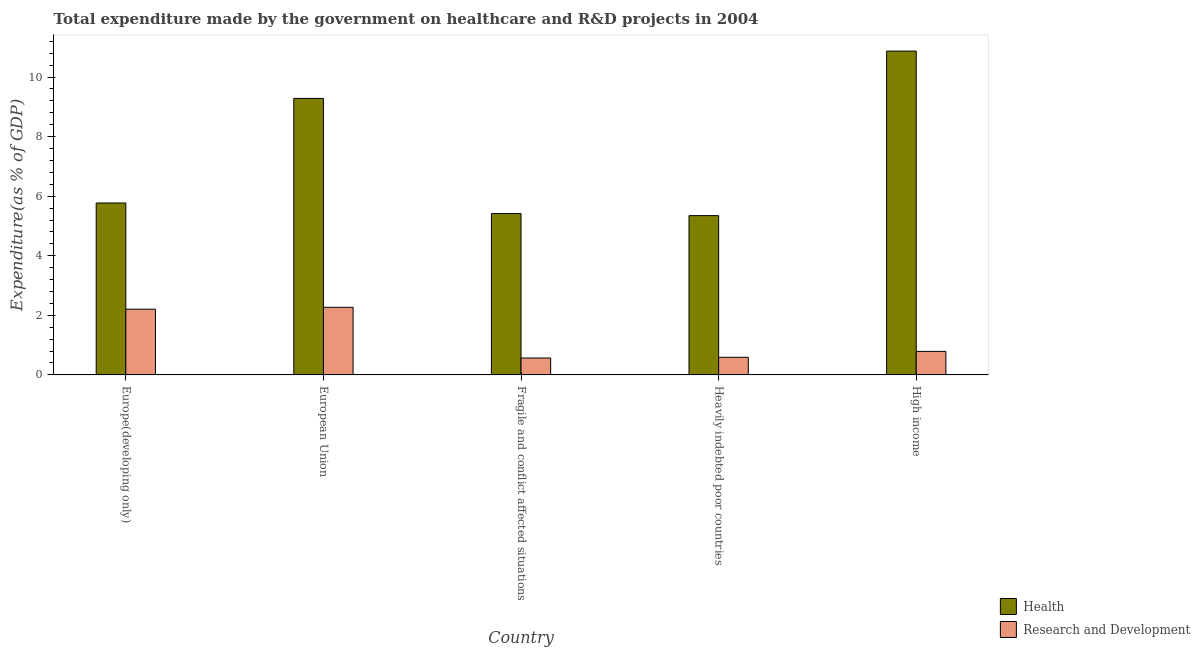How many different coloured bars are there?
Your answer should be very brief. 2. How many bars are there on the 3rd tick from the right?
Your answer should be very brief. 2. What is the label of the 4th group of bars from the left?
Provide a succinct answer. Heavily indebted poor countries. In how many cases, is the number of bars for a given country not equal to the number of legend labels?
Offer a terse response. 0. What is the expenditure in healthcare in Fragile and conflict affected situations?
Ensure brevity in your answer.  5.42. Across all countries, what is the maximum expenditure in healthcare?
Ensure brevity in your answer.  10.87. Across all countries, what is the minimum expenditure in healthcare?
Make the answer very short. 5.35. In which country was the expenditure in r&d maximum?
Provide a succinct answer. European Union. In which country was the expenditure in healthcare minimum?
Keep it short and to the point. Heavily indebted poor countries. What is the total expenditure in healthcare in the graph?
Offer a very short reply. 36.69. What is the difference between the expenditure in healthcare in European Union and that in Heavily indebted poor countries?
Your answer should be very brief. 3.94. What is the difference between the expenditure in r&d in European Union and the expenditure in healthcare in Fragile and conflict affected situations?
Make the answer very short. -3.15. What is the average expenditure in healthcare per country?
Provide a short and direct response. 7.34. What is the difference between the expenditure in r&d and expenditure in healthcare in Heavily indebted poor countries?
Offer a very short reply. -4.76. In how many countries, is the expenditure in healthcare greater than 6.4 %?
Offer a very short reply. 2. What is the ratio of the expenditure in healthcare in Fragile and conflict affected situations to that in High income?
Keep it short and to the point. 0.5. Is the expenditure in healthcare in Heavily indebted poor countries less than that in High income?
Offer a very short reply. Yes. What is the difference between the highest and the second highest expenditure in healthcare?
Offer a very short reply. 1.59. What is the difference between the highest and the lowest expenditure in healthcare?
Keep it short and to the point. 5.53. In how many countries, is the expenditure in r&d greater than the average expenditure in r&d taken over all countries?
Your answer should be very brief. 2. Is the sum of the expenditure in healthcare in European Union and Fragile and conflict affected situations greater than the maximum expenditure in r&d across all countries?
Offer a very short reply. Yes. What does the 2nd bar from the left in Fragile and conflict affected situations represents?
Provide a succinct answer. Research and Development. What does the 1st bar from the right in European Union represents?
Offer a terse response. Research and Development. How many countries are there in the graph?
Keep it short and to the point. 5. How many legend labels are there?
Ensure brevity in your answer.  2. How are the legend labels stacked?
Offer a terse response. Vertical. What is the title of the graph?
Your answer should be very brief. Total expenditure made by the government on healthcare and R&D projects in 2004. Does "Infant" appear as one of the legend labels in the graph?
Offer a very short reply. No. What is the label or title of the Y-axis?
Offer a terse response. Expenditure(as % of GDP). What is the Expenditure(as % of GDP) in Health in Europe(developing only)?
Provide a short and direct response. 5.77. What is the Expenditure(as % of GDP) of Research and Development in Europe(developing only)?
Make the answer very short. 2.21. What is the Expenditure(as % of GDP) of Health in European Union?
Offer a terse response. 9.28. What is the Expenditure(as % of GDP) of Research and Development in European Union?
Offer a terse response. 2.27. What is the Expenditure(as % of GDP) in Health in Fragile and conflict affected situations?
Offer a very short reply. 5.42. What is the Expenditure(as % of GDP) of Research and Development in Fragile and conflict affected situations?
Offer a very short reply. 0.57. What is the Expenditure(as % of GDP) in Health in Heavily indebted poor countries?
Your answer should be very brief. 5.35. What is the Expenditure(as % of GDP) in Research and Development in Heavily indebted poor countries?
Provide a short and direct response. 0.59. What is the Expenditure(as % of GDP) of Health in High income?
Provide a succinct answer. 10.87. What is the Expenditure(as % of GDP) of Research and Development in High income?
Offer a terse response. 0.79. Across all countries, what is the maximum Expenditure(as % of GDP) of Health?
Offer a terse response. 10.87. Across all countries, what is the maximum Expenditure(as % of GDP) of Research and Development?
Your response must be concise. 2.27. Across all countries, what is the minimum Expenditure(as % of GDP) of Health?
Offer a very short reply. 5.35. Across all countries, what is the minimum Expenditure(as % of GDP) of Research and Development?
Offer a very short reply. 0.57. What is the total Expenditure(as % of GDP) of Health in the graph?
Provide a succinct answer. 36.69. What is the total Expenditure(as % of GDP) in Research and Development in the graph?
Your answer should be very brief. 6.43. What is the difference between the Expenditure(as % of GDP) of Health in Europe(developing only) and that in European Union?
Provide a short and direct response. -3.51. What is the difference between the Expenditure(as % of GDP) in Research and Development in Europe(developing only) and that in European Union?
Provide a short and direct response. -0.06. What is the difference between the Expenditure(as % of GDP) of Health in Europe(developing only) and that in Fragile and conflict affected situations?
Your answer should be compact. 0.36. What is the difference between the Expenditure(as % of GDP) in Research and Development in Europe(developing only) and that in Fragile and conflict affected situations?
Your answer should be very brief. 1.64. What is the difference between the Expenditure(as % of GDP) of Health in Europe(developing only) and that in Heavily indebted poor countries?
Offer a terse response. 0.42. What is the difference between the Expenditure(as % of GDP) of Research and Development in Europe(developing only) and that in Heavily indebted poor countries?
Your answer should be compact. 1.61. What is the difference between the Expenditure(as % of GDP) of Health in Europe(developing only) and that in High income?
Your answer should be very brief. -5.1. What is the difference between the Expenditure(as % of GDP) of Research and Development in Europe(developing only) and that in High income?
Your response must be concise. 1.42. What is the difference between the Expenditure(as % of GDP) of Health in European Union and that in Fragile and conflict affected situations?
Make the answer very short. 3.87. What is the difference between the Expenditure(as % of GDP) of Research and Development in European Union and that in Fragile and conflict affected situations?
Provide a short and direct response. 1.7. What is the difference between the Expenditure(as % of GDP) of Health in European Union and that in Heavily indebted poor countries?
Offer a very short reply. 3.94. What is the difference between the Expenditure(as % of GDP) in Research and Development in European Union and that in Heavily indebted poor countries?
Offer a terse response. 1.68. What is the difference between the Expenditure(as % of GDP) of Health in European Union and that in High income?
Keep it short and to the point. -1.59. What is the difference between the Expenditure(as % of GDP) in Research and Development in European Union and that in High income?
Provide a succinct answer. 1.48. What is the difference between the Expenditure(as % of GDP) in Health in Fragile and conflict affected situations and that in Heavily indebted poor countries?
Your answer should be very brief. 0.07. What is the difference between the Expenditure(as % of GDP) in Research and Development in Fragile and conflict affected situations and that in Heavily indebted poor countries?
Offer a very short reply. -0.03. What is the difference between the Expenditure(as % of GDP) of Health in Fragile and conflict affected situations and that in High income?
Your answer should be very brief. -5.46. What is the difference between the Expenditure(as % of GDP) in Research and Development in Fragile and conflict affected situations and that in High income?
Offer a terse response. -0.22. What is the difference between the Expenditure(as % of GDP) in Health in Heavily indebted poor countries and that in High income?
Give a very brief answer. -5.53. What is the difference between the Expenditure(as % of GDP) of Research and Development in Heavily indebted poor countries and that in High income?
Ensure brevity in your answer.  -0.2. What is the difference between the Expenditure(as % of GDP) of Health in Europe(developing only) and the Expenditure(as % of GDP) of Research and Development in European Union?
Keep it short and to the point. 3.5. What is the difference between the Expenditure(as % of GDP) of Health in Europe(developing only) and the Expenditure(as % of GDP) of Research and Development in Fragile and conflict affected situations?
Ensure brevity in your answer.  5.2. What is the difference between the Expenditure(as % of GDP) in Health in Europe(developing only) and the Expenditure(as % of GDP) in Research and Development in Heavily indebted poor countries?
Ensure brevity in your answer.  5.18. What is the difference between the Expenditure(as % of GDP) in Health in Europe(developing only) and the Expenditure(as % of GDP) in Research and Development in High income?
Your answer should be very brief. 4.98. What is the difference between the Expenditure(as % of GDP) of Health in European Union and the Expenditure(as % of GDP) of Research and Development in Fragile and conflict affected situations?
Give a very brief answer. 8.72. What is the difference between the Expenditure(as % of GDP) in Health in European Union and the Expenditure(as % of GDP) in Research and Development in Heavily indebted poor countries?
Your response must be concise. 8.69. What is the difference between the Expenditure(as % of GDP) of Health in European Union and the Expenditure(as % of GDP) of Research and Development in High income?
Make the answer very short. 8.49. What is the difference between the Expenditure(as % of GDP) in Health in Fragile and conflict affected situations and the Expenditure(as % of GDP) in Research and Development in Heavily indebted poor countries?
Make the answer very short. 4.82. What is the difference between the Expenditure(as % of GDP) of Health in Fragile and conflict affected situations and the Expenditure(as % of GDP) of Research and Development in High income?
Your answer should be very brief. 4.63. What is the difference between the Expenditure(as % of GDP) in Health in Heavily indebted poor countries and the Expenditure(as % of GDP) in Research and Development in High income?
Your response must be concise. 4.56. What is the average Expenditure(as % of GDP) in Health per country?
Keep it short and to the point. 7.34. What is the average Expenditure(as % of GDP) in Research and Development per country?
Give a very brief answer. 1.29. What is the difference between the Expenditure(as % of GDP) of Health and Expenditure(as % of GDP) of Research and Development in Europe(developing only)?
Your response must be concise. 3.57. What is the difference between the Expenditure(as % of GDP) in Health and Expenditure(as % of GDP) in Research and Development in European Union?
Provide a succinct answer. 7.01. What is the difference between the Expenditure(as % of GDP) of Health and Expenditure(as % of GDP) of Research and Development in Fragile and conflict affected situations?
Offer a very short reply. 4.85. What is the difference between the Expenditure(as % of GDP) in Health and Expenditure(as % of GDP) in Research and Development in Heavily indebted poor countries?
Keep it short and to the point. 4.76. What is the difference between the Expenditure(as % of GDP) of Health and Expenditure(as % of GDP) of Research and Development in High income?
Offer a very short reply. 10.08. What is the ratio of the Expenditure(as % of GDP) in Health in Europe(developing only) to that in European Union?
Make the answer very short. 0.62. What is the ratio of the Expenditure(as % of GDP) in Research and Development in Europe(developing only) to that in European Union?
Your response must be concise. 0.97. What is the ratio of the Expenditure(as % of GDP) in Health in Europe(developing only) to that in Fragile and conflict affected situations?
Provide a succinct answer. 1.07. What is the ratio of the Expenditure(as % of GDP) of Research and Development in Europe(developing only) to that in Fragile and conflict affected situations?
Give a very brief answer. 3.89. What is the ratio of the Expenditure(as % of GDP) in Health in Europe(developing only) to that in Heavily indebted poor countries?
Your answer should be compact. 1.08. What is the ratio of the Expenditure(as % of GDP) of Research and Development in Europe(developing only) to that in Heavily indebted poor countries?
Your answer should be very brief. 3.72. What is the ratio of the Expenditure(as % of GDP) in Health in Europe(developing only) to that in High income?
Provide a succinct answer. 0.53. What is the ratio of the Expenditure(as % of GDP) in Research and Development in Europe(developing only) to that in High income?
Offer a terse response. 2.79. What is the ratio of the Expenditure(as % of GDP) of Health in European Union to that in Fragile and conflict affected situations?
Ensure brevity in your answer.  1.71. What is the ratio of the Expenditure(as % of GDP) in Research and Development in European Union to that in Fragile and conflict affected situations?
Your answer should be very brief. 4. What is the ratio of the Expenditure(as % of GDP) in Health in European Union to that in Heavily indebted poor countries?
Your answer should be compact. 1.74. What is the ratio of the Expenditure(as % of GDP) of Research and Development in European Union to that in Heavily indebted poor countries?
Your answer should be compact. 3.83. What is the ratio of the Expenditure(as % of GDP) of Health in European Union to that in High income?
Give a very brief answer. 0.85. What is the ratio of the Expenditure(as % of GDP) of Research and Development in European Union to that in High income?
Your response must be concise. 2.87. What is the ratio of the Expenditure(as % of GDP) in Health in Fragile and conflict affected situations to that in Heavily indebted poor countries?
Offer a very short reply. 1.01. What is the ratio of the Expenditure(as % of GDP) of Research and Development in Fragile and conflict affected situations to that in Heavily indebted poor countries?
Give a very brief answer. 0.96. What is the ratio of the Expenditure(as % of GDP) of Health in Fragile and conflict affected situations to that in High income?
Provide a short and direct response. 0.5. What is the ratio of the Expenditure(as % of GDP) in Research and Development in Fragile and conflict affected situations to that in High income?
Provide a short and direct response. 0.72. What is the ratio of the Expenditure(as % of GDP) in Health in Heavily indebted poor countries to that in High income?
Your response must be concise. 0.49. What is the ratio of the Expenditure(as % of GDP) of Research and Development in Heavily indebted poor countries to that in High income?
Your answer should be very brief. 0.75. What is the difference between the highest and the second highest Expenditure(as % of GDP) of Health?
Keep it short and to the point. 1.59. What is the difference between the highest and the second highest Expenditure(as % of GDP) in Research and Development?
Offer a terse response. 0.06. What is the difference between the highest and the lowest Expenditure(as % of GDP) in Health?
Your answer should be very brief. 5.53. What is the difference between the highest and the lowest Expenditure(as % of GDP) in Research and Development?
Make the answer very short. 1.7. 